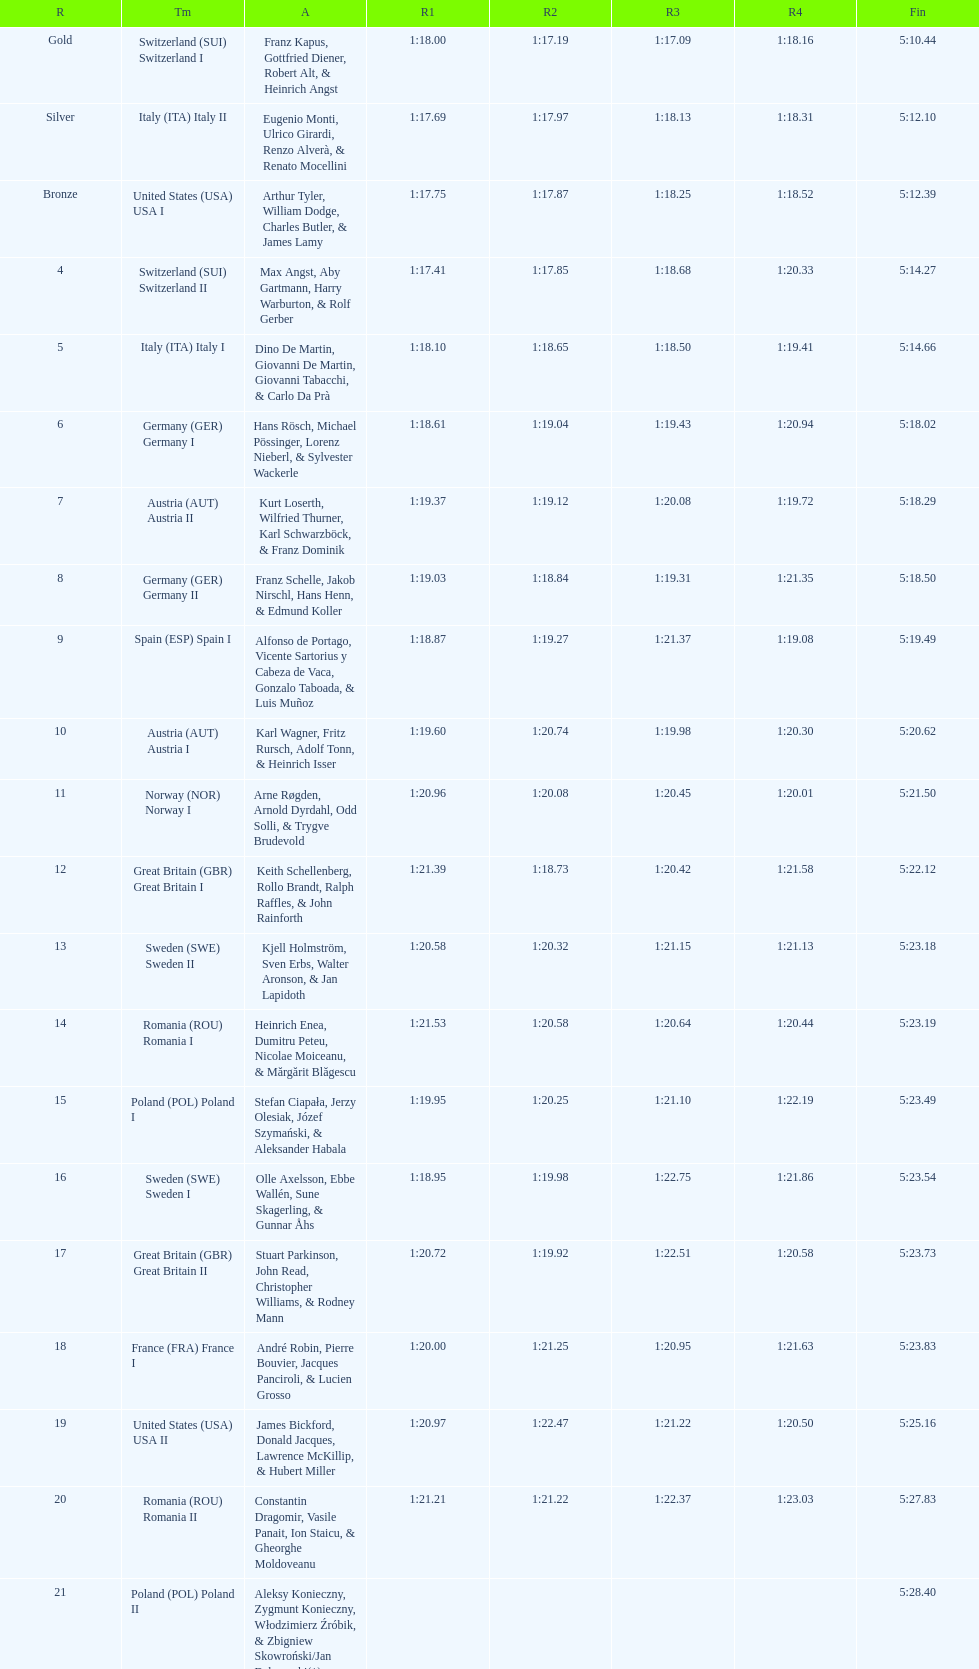Which team had the most time? Poland. 